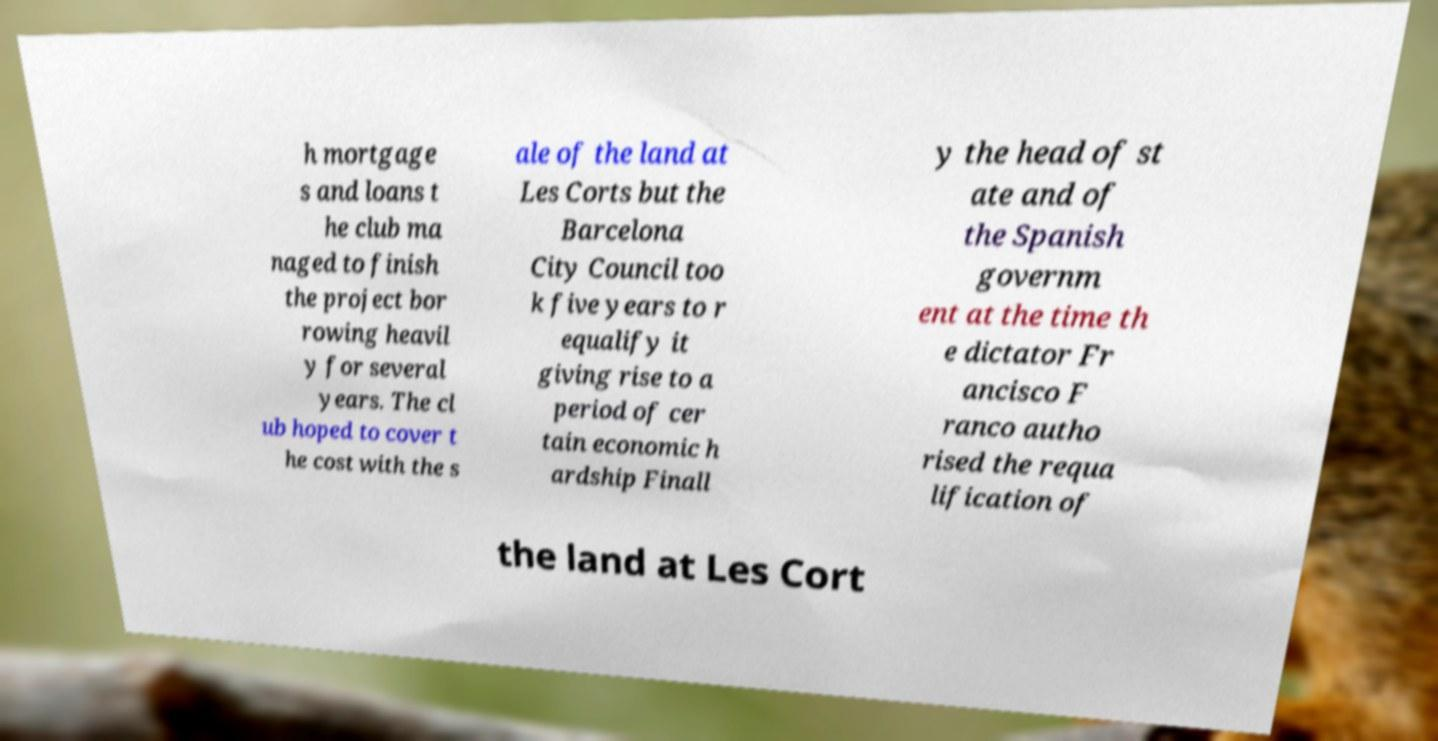Please read and relay the text visible in this image. What does it say? h mortgage s and loans t he club ma naged to finish the project bor rowing heavil y for several years. The cl ub hoped to cover t he cost with the s ale of the land at Les Corts but the Barcelona City Council too k five years to r equalify it giving rise to a period of cer tain economic h ardship Finall y the head of st ate and of the Spanish governm ent at the time th e dictator Fr ancisco F ranco autho rised the requa lification of the land at Les Cort 